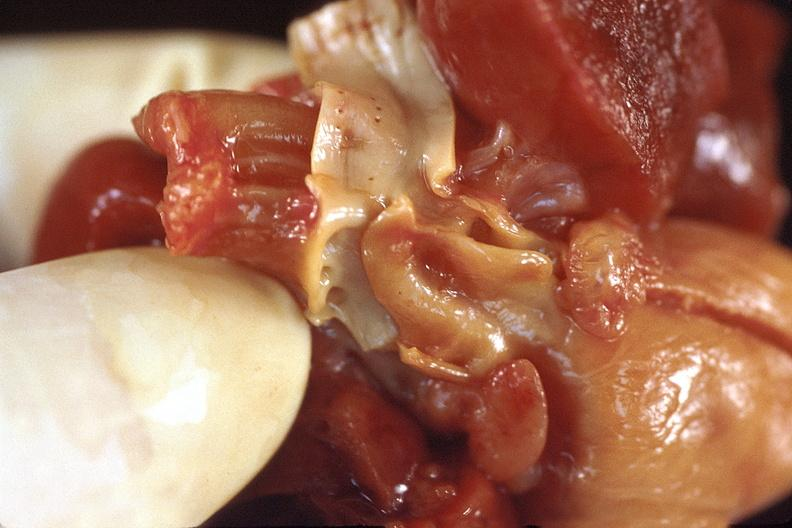what is present?
Answer the question using a single word or phrase. Cardiovascular 